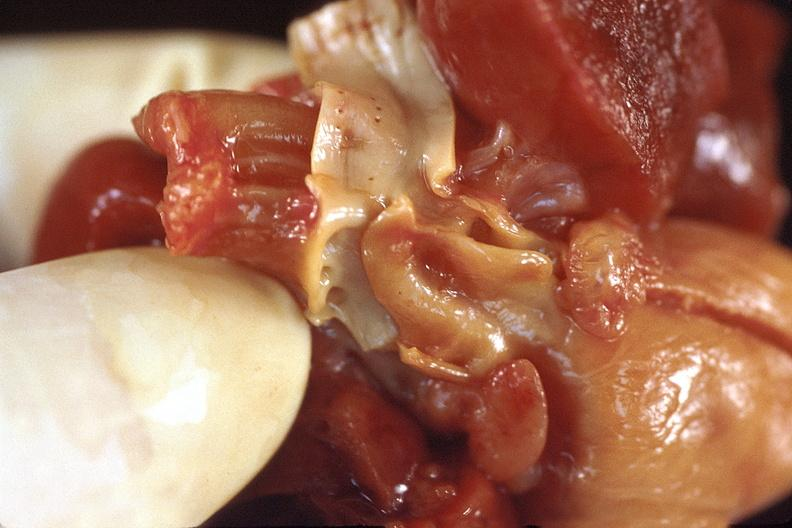what is present?
Answer the question using a single word or phrase. Cardiovascular 